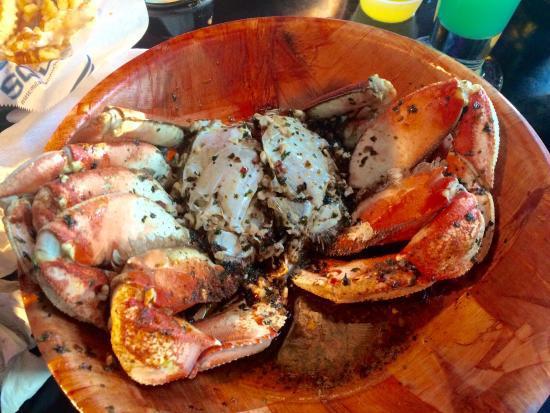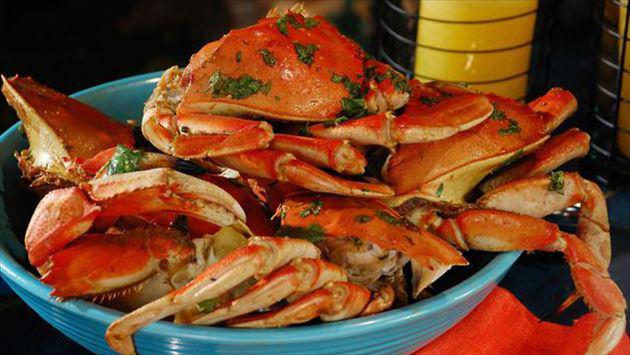The first image is the image on the left, the second image is the image on the right. Examine the images to the left and right. Is the description "There are crab legs separated from the body." accurate? Answer yes or no. No. The first image is the image on the left, the second image is the image on the right. For the images displayed, is the sentence "A single whole crab is on a white plate with dipping sauce next to it." factually correct? Answer yes or no. No. 